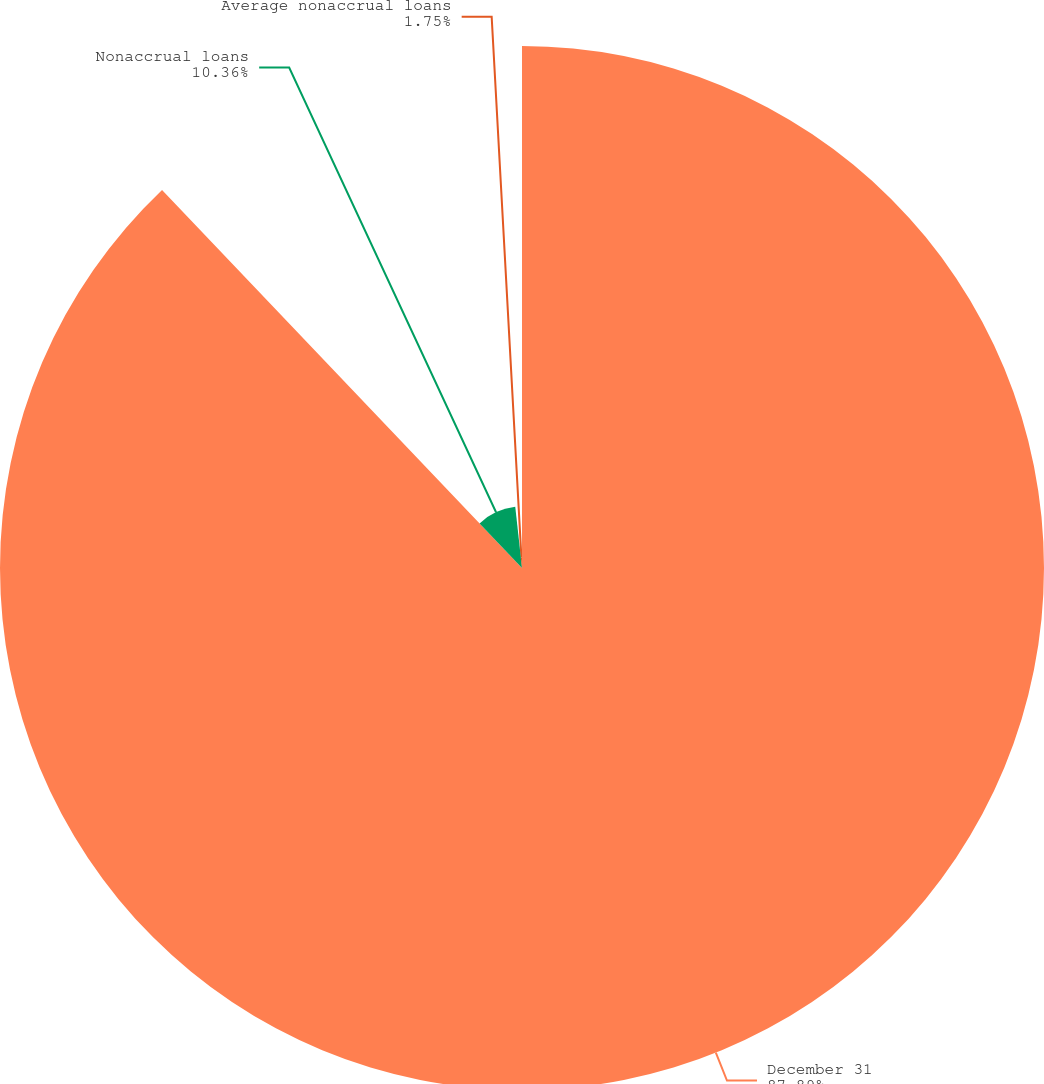<chart> <loc_0><loc_0><loc_500><loc_500><pie_chart><fcel>December 31<fcel>Nonaccrual loans<fcel>Average nonaccrual loans<nl><fcel>87.89%<fcel>10.36%<fcel>1.75%<nl></chart> 